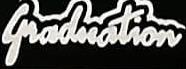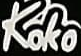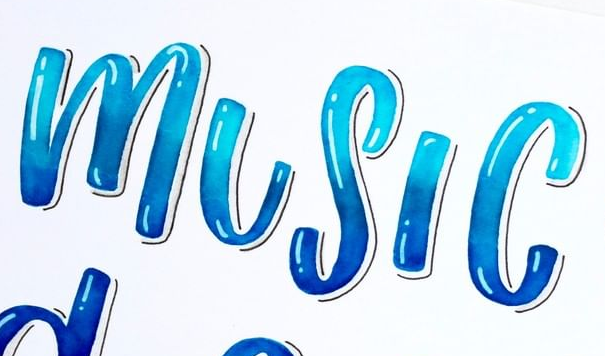Read the text from these images in sequence, separated by a semicolon. Graduation; Koko; MUSIC 